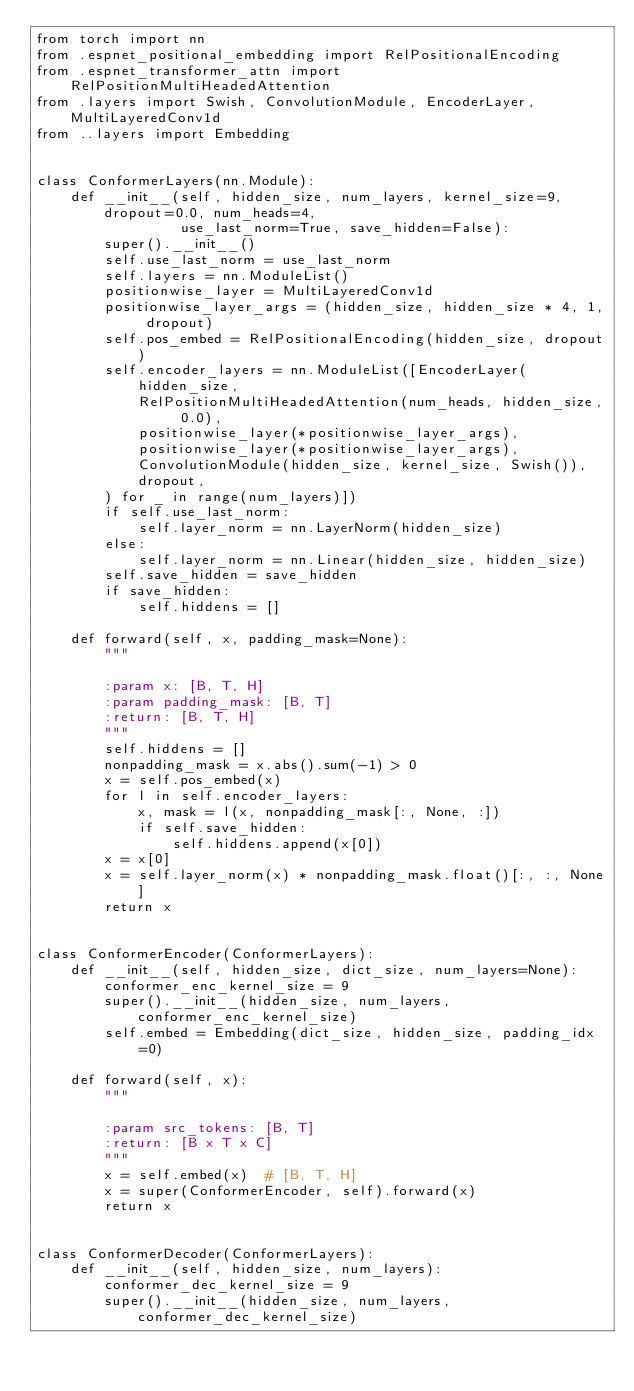<code> <loc_0><loc_0><loc_500><loc_500><_Python_>from torch import nn
from .espnet_positional_embedding import RelPositionalEncoding
from .espnet_transformer_attn import RelPositionMultiHeadedAttention
from .layers import Swish, ConvolutionModule, EncoderLayer, MultiLayeredConv1d
from ..layers import Embedding


class ConformerLayers(nn.Module):
    def __init__(self, hidden_size, num_layers, kernel_size=9, dropout=0.0, num_heads=4,
                 use_last_norm=True, save_hidden=False):
        super().__init__()
        self.use_last_norm = use_last_norm
        self.layers = nn.ModuleList()
        positionwise_layer = MultiLayeredConv1d
        positionwise_layer_args = (hidden_size, hidden_size * 4, 1, dropout)
        self.pos_embed = RelPositionalEncoding(hidden_size, dropout)
        self.encoder_layers = nn.ModuleList([EncoderLayer(
            hidden_size,
            RelPositionMultiHeadedAttention(num_heads, hidden_size, 0.0),
            positionwise_layer(*positionwise_layer_args),
            positionwise_layer(*positionwise_layer_args),
            ConvolutionModule(hidden_size, kernel_size, Swish()),
            dropout,
        ) for _ in range(num_layers)])
        if self.use_last_norm:
            self.layer_norm = nn.LayerNorm(hidden_size)
        else:
            self.layer_norm = nn.Linear(hidden_size, hidden_size)
        self.save_hidden = save_hidden
        if save_hidden:
            self.hiddens = []

    def forward(self, x, padding_mask=None):
        """

        :param x: [B, T, H]
        :param padding_mask: [B, T]
        :return: [B, T, H]
        """
        self.hiddens = []
        nonpadding_mask = x.abs().sum(-1) > 0
        x = self.pos_embed(x)
        for l in self.encoder_layers:
            x, mask = l(x, nonpadding_mask[:, None, :])
            if self.save_hidden:
                self.hiddens.append(x[0])
        x = x[0]
        x = self.layer_norm(x) * nonpadding_mask.float()[:, :, None]
        return x


class ConformerEncoder(ConformerLayers):
    def __init__(self, hidden_size, dict_size, num_layers=None):
        conformer_enc_kernel_size = 9
        super().__init__(hidden_size, num_layers, conformer_enc_kernel_size)
        self.embed = Embedding(dict_size, hidden_size, padding_idx=0)

    def forward(self, x):
        """

        :param src_tokens: [B, T]
        :return: [B x T x C]
        """
        x = self.embed(x)  # [B, T, H]
        x = super(ConformerEncoder, self).forward(x)
        return x


class ConformerDecoder(ConformerLayers):
    def __init__(self, hidden_size, num_layers):
        conformer_dec_kernel_size = 9
        super().__init__(hidden_size, num_layers, conformer_dec_kernel_size)
</code> 